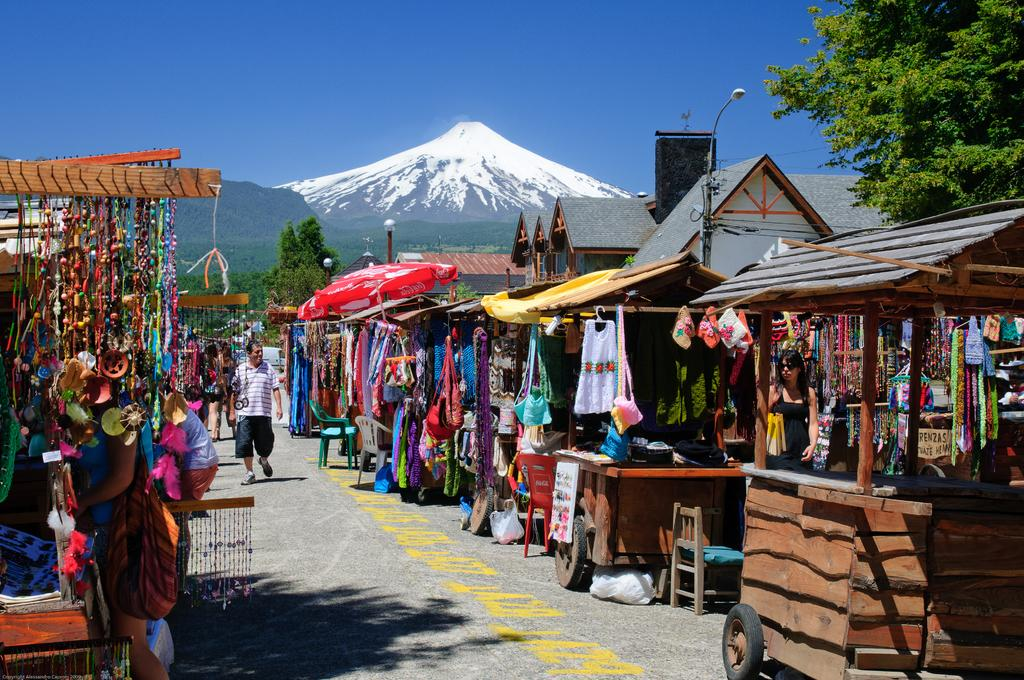What types of establishments can be seen in the image? There are different types of shops in the image. What can be seen in the distance behind the shops? There are trees and mountains in the background of the image. What is the condition of the sky in the image? The sky is clear in the background of the image. Is there a power outage in the image? There is no indication of a power outage in the image; the shops and background are clearly visible. Can you see a camp in the image? There is no camp present in the image; it features different types of shops, trees, mountains, and a clear sky. 